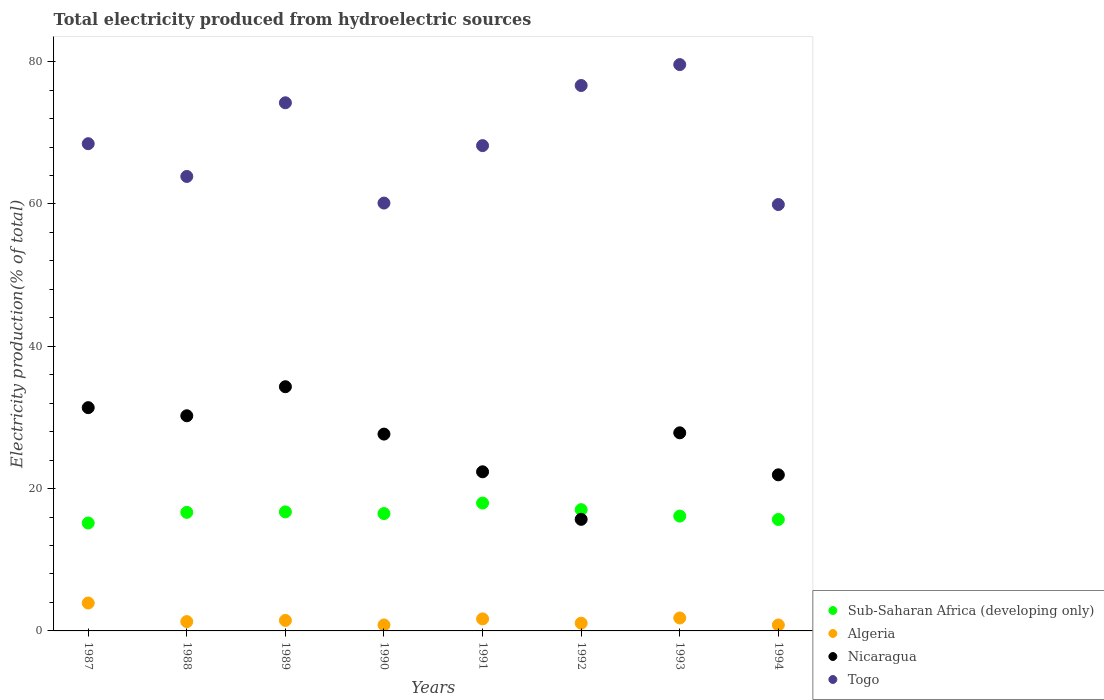Is the number of dotlines equal to the number of legend labels?
Provide a short and direct response. Yes. What is the total electricity produced in Nicaragua in 1988?
Provide a succinct answer. 30.23. Across all years, what is the maximum total electricity produced in Algeria?
Your answer should be compact. 3.92. Across all years, what is the minimum total electricity produced in Togo?
Your response must be concise. 59.92. In which year was the total electricity produced in Sub-Saharan Africa (developing only) maximum?
Your answer should be compact. 1991. What is the total total electricity produced in Togo in the graph?
Your response must be concise. 551.03. What is the difference between the total electricity produced in Sub-Saharan Africa (developing only) in 1992 and that in 1994?
Provide a succinct answer. 1.38. What is the difference between the total electricity produced in Nicaragua in 1993 and the total electricity produced in Algeria in 1987?
Your response must be concise. 23.92. What is the average total electricity produced in Togo per year?
Your answer should be compact. 68.88. In the year 1992, what is the difference between the total electricity produced in Sub-Saharan Africa (developing only) and total electricity produced in Nicaragua?
Your answer should be very brief. 1.36. What is the ratio of the total electricity produced in Togo in 1992 to that in 1994?
Provide a succinct answer. 1.28. Is the total electricity produced in Nicaragua in 1992 less than that in 1994?
Keep it short and to the point. Yes. What is the difference between the highest and the second highest total electricity produced in Togo?
Your answer should be compact. 2.94. What is the difference between the highest and the lowest total electricity produced in Nicaragua?
Provide a short and direct response. 18.64. Is it the case that in every year, the sum of the total electricity produced in Togo and total electricity produced in Algeria  is greater than the total electricity produced in Nicaragua?
Offer a very short reply. Yes. Are the values on the major ticks of Y-axis written in scientific E-notation?
Make the answer very short. No. Does the graph contain grids?
Offer a terse response. No. Where does the legend appear in the graph?
Make the answer very short. Bottom right. How are the legend labels stacked?
Make the answer very short. Vertical. What is the title of the graph?
Your answer should be compact. Total electricity produced from hydroelectric sources. Does "Albania" appear as one of the legend labels in the graph?
Keep it short and to the point. No. What is the Electricity production(% of total) in Sub-Saharan Africa (developing only) in 1987?
Offer a terse response. 15.17. What is the Electricity production(% of total) of Algeria in 1987?
Make the answer very short. 3.92. What is the Electricity production(% of total) in Nicaragua in 1987?
Your response must be concise. 31.38. What is the Electricity production(% of total) of Togo in 1987?
Ensure brevity in your answer.  68.47. What is the Electricity production(% of total) in Sub-Saharan Africa (developing only) in 1988?
Offer a very short reply. 16.66. What is the Electricity production(% of total) of Algeria in 1988?
Provide a succinct answer. 1.31. What is the Electricity production(% of total) of Nicaragua in 1988?
Ensure brevity in your answer.  30.23. What is the Electricity production(% of total) in Togo in 1988?
Give a very brief answer. 63.87. What is the Electricity production(% of total) of Sub-Saharan Africa (developing only) in 1989?
Give a very brief answer. 16.73. What is the Electricity production(% of total) in Algeria in 1989?
Ensure brevity in your answer.  1.47. What is the Electricity production(% of total) in Nicaragua in 1989?
Offer a very short reply. 34.32. What is the Electricity production(% of total) in Togo in 1989?
Provide a succinct answer. 74.22. What is the Electricity production(% of total) of Sub-Saharan Africa (developing only) in 1990?
Give a very brief answer. 16.49. What is the Electricity production(% of total) of Algeria in 1990?
Provide a short and direct response. 0.84. What is the Electricity production(% of total) of Nicaragua in 1990?
Provide a short and direct response. 27.66. What is the Electricity production(% of total) of Togo in 1990?
Offer a very short reply. 60.13. What is the Electricity production(% of total) in Sub-Saharan Africa (developing only) in 1991?
Provide a short and direct response. 17.97. What is the Electricity production(% of total) of Algeria in 1991?
Keep it short and to the point. 1.69. What is the Electricity production(% of total) of Nicaragua in 1991?
Your answer should be very brief. 22.36. What is the Electricity production(% of total) of Togo in 1991?
Offer a terse response. 68.2. What is the Electricity production(% of total) in Sub-Saharan Africa (developing only) in 1992?
Offer a very short reply. 17.04. What is the Electricity production(% of total) in Algeria in 1992?
Your answer should be compact. 1.09. What is the Electricity production(% of total) in Nicaragua in 1992?
Your response must be concise. 15.68. What is the Electricity production(% of total) in Togo in 1992?
Make the answer very short. 76.65. What is the Electricity production(% of total) of Sub-Saharan Africa (developing only) in 1993?
Provide a succinct answer. 16.14. What is the Electricity production(% of total) in Algeria in 1993?
Offer a very short reply. 1.82. What is the Electricity production(% of total) in Nicaragua in 1993?
Make the answer very short. 27.84. What is the Electricity production(% of total) of Togo in 1993?
Your answer should be compact. 79.58. What is the Electricity production(% of total) of Sub-Saharan Africa (developing only) in 1994?
Make the answer very short. 15.66. What is the Electricity production(% of total) in Algeria in 1994?
Offer a very short reply. 0.83. What is the Electricity production(% of total) of Nicaragua in 1994?
Make the answer very short. 21.94. What is the Electricity production(% of total) of Togo in 1994?
Keep it short and to the point. 59.92. Across all years, what is the maximum Electricity production(% of total) in Sub-Saharan Africa (developing only)?
Ensure brevity in your answer.  17.97. Across all years, what is the maximum Electricity production(% of total) of Algeria?
Make the answer very short. 3.92. Across all years, what is the maximum Electricity production(% of total) of Nicaragua?
Your response must be concise. 34.32. Across all years, what is the maximum Electricity production(% of total) of Togo?
Your answer should be compact. 79.58. Across all years, what is the minimum Electricity production(% of total) in Sub-Saharan Africa (developing only)?
Keep it short and to the point. 15.17. Across all years, what is the minimum Electricity production(% of total) in Algeria?
Provide a succinct answer. 0.83. Across all years, what is the minimum Electricity production(% of total) in Nicaragua?
Your answer should be very brief. 15.68. Across all years, what is the minimum Electricity production(% of total) in Togo?
Offer a very short reply. 59.92. What is the total Electricity production(% of total) of Sub-Saharan Africa (developing only) in the graph?
Offer a terse response. 131.85. What is the total Electricity production(% of total) in Algeria in the graph?
Provide a succinct answer. 12.98. What is the total Electricity production(% of total) in Nicaragua in the graph?
Your answer should be compact. 211.41. What is the total Electricity production(% of total) of Togo in the graph?
Make the answer very short. 551.03. What is the difference between the Electricity production(% of total) in Sub-Saharan Africa (developing only) in 1987 and that in 1988?
Your answer should be compact. -1.5. What is the difference between the Electricity production(% of total) of Algeria in 1987 and that in 1988?
Offer a very short reply. 2.61. What is the difference between the Electricity production(% of total) of Nicaragua in 1987 and that in 1988?
Provide a succinct answer. 1.14. What is the difference between the Electricity production(% of total) of Togo in 1987 and that in 1988?
Make the answer very short. 4.6. What is the difference between the Electricity production(% of total) of Sub-Saharan Africa (developing only) in 1987 and that in 1989?
Your response must be concise. -1.56. What is the difference between the Electricity production(% of total) in Algeria in 1987 and that in 1989?
Offer a terse response. 2.45. What is the difference between the Electricity production(% of total) in Nicaragua in 1987 and that in 1989?
Provide a short and direct response. -2.94. What is the difference between the Electricity production(% of total) in Togo in 1987 and that in 1989?
Give a very brief answer. -5.75. What is the difference between the Electricity production(% of total) of Sub-Saharan Africa (developing only) in 1987 and that in 1990?
Make the answer very short. -1.33. What is the difference between the Electricity production(% of total) of Algeria in 1987 and that in 1990?
Offer a terse response. 3.08. What is the difference between the Electricity production(% of total) in Nicaragua in 1987 and that in 1990?
Give a very brief answer. 3.72. What is the difference between the Electricity production(% of total) of Togo in 1987 and that in 1990?
Your response must be concise. 8.34. What is the difference between the Electricity production(% of total) of Sub-Saharan Africa (developing only) in 1987 and that in 1991?
Provide a short and direct response. -2.8. What is the difference between the Electricity production(% of total) of Algeria in 1987 and that in 1991?
Provide a succinct answer. 2.23. What is the difference between the Electricity production(% of total) of Nicaragua in 1987 and that in 1991?
Offer a very short reply. 9.01. What is the difference between the Electricity production(% of total) in Togo in 1987 and that in 1991?
Give a very brief answer. 0.27. What is the difference between the Electricity production(% of total) in Sub-Saharan Africa (developing only) in 1987 and that in 1992?
Provide a succinct answer. -1.87. What is the difference between the Electricity production(% of total) of Algeria in 1987 and that in 1992?
Offer a terse response. 2.83. What is the difference between the Electricity production(% of total) of Nicaragua in 1987 and that in 1992?
Give a very brief answer. 15.7. What is the difference between the Electricity production(% of total) in Togo in 1987 and that in 1992?
Provide a succinct answer. -8.18. What is the difference between the Electricity production(% of total) of Sub-Saharan Africa (developing only) in 1987 and that in 1993?
Your answer should be compact. -0.97. What is the difference between the Electricity production(% of total) in Algeria in 1987 and that in 1993?
Your answer should be very brief. 2.1. What is the difference between the Electricity production(% of total) in Nicaragua in 1987 and that in 1993?
Your answer should be very brief. 3.54. What is the difference between the Electricity production(% of total) of Togo in 1987 and that in 1993?
Your answer should be very brief. -11.12. What is the difference between the Electricity production(% of total) of Sub-Saharan Africa (developing only) in 1987 and that in 1994?
Make the answer very short. -0.5. What is the difference between the Electricity production(% of total) of Algeria in 1987 and that in 1994?
Your response must be concise. 3.09. What is the difference between the Electricity production(% of total) in Nicaragua in 1987 and that in 1994?
Your answer should be compact. 9.44. What is the difference between the Electricity production(% of total) in Togo in 1987 and that in 1994?
Your answer should be very brief. 8.55. What is the difference between the Electricity production(% of total) in Sub-Saharan Africa (developing only) in 1988 and that in 1989?
Your answer should be compact. -0.07. What is the difference between the Electricity production(% of total) of Algeria in 1988 and that in 1989?
Your answer should be very brief. -0.16. What is the difference between the Electricity production(% of total) of Nicaragua in 1988 and that in 1989?
Your answer should be compact. -4.08. What is the difference between the Electricity production(% of total) in Togo in 1988 and that in 1989?
Give a very brief answer. -10.35. What is the difference between the Electricity production(% of total) in Sub-Saharan Africa (developing only) in 1988 and that in 1990?
Give a very brief answer. 0.17. What is the difference between the Electricity production(% of total) of Algeria in 1988 and that in 1990?
Make the answer very short. 0.47. What is the difference between the Electricity production(% of total) of Nicaragua in 1988 and that in 1990?
Your answer should be compact. 2.57. What is the difference between the Electricity production(% of total) in Togo in 1988 and that in 1990?
Offer a very short reply. 3.74. What is the difference between the Electricity production(% of total) in Sub-Saharan Africa (developing only) in 1988 and that in 1991?
Make the answer very short. -1.31. What is the difference between the Electricity production(% of total) in Algeria in 1988 and that in 1991?
Offer a terse response. -0.38. What is the difference between the Electricity production(% of total) of Nicaragua in 1988 and that in 1991?
Make the answer very short. 7.87. What is the difference between the Electricity production(% of total) in Togo in 1988 and that in 1991?
Keep it short and to the point. -4.33. What is the difference between the Electricity production(% of total) of Sub-Saharan Africa (developing only) in 1988 and that in 1992?
Your response must be concise. -0.38. What is the difference between the Electricity production(% of total) in Algeria in 1988 and that in 1992?
Provide a short and direct response. 0.22. What is the difference between the Electricity production(% of total) of Nicaragua in 1988 and that in 1992?
Your response must be concise. 14.55. What is the difference between the Electricity production(% of total) of Togo in 1988 and that in 1992?
Ensure brevity in your answer.  -12.78. What is the difference between the Electricity production(% of total) of Sub-Saharan Africa (developing only) in 1988 and that in 1993?
Make the answer very short. 0.52. What is the difference between the Electricity production(% of total) in Algeria in 1988 and that in 1993?
Offer a terse response. -0.51. What is the difference between the Electricity production(% of total) of Nicaragua in 1988 and that in 1993?
Provide a succinct answer. 2.4. What is the difference between the Electricity production(% of total) of Togo in 1988 and that in 1993?
Your answer should be very brief. -15.72. What is the difference between the Electricity production(% of total) of Sub-Saharan Africa (developing only) in 1988 and that in 1994?
Give a very brief answer. 1. What is the difference between the Electricity production(% of total) in Algeria in 1988 and that in 1994?
Offer a very short reply. 0.48. What is the difference between the Electricity production(% of total) of Nicaragua in 1988 and that in 1994?
Offer a very short reply. 8.3. What is the difference between the Electricity production(% of total) in Togo in 1988 and that in 1994?
Your answer should be compact. 3.95. What is the difference between the Electricity production(% of total) of Sub-Saharan Africa (developing only) in 1989 and that in 1990?
Your answer should be very brief. 0.24. What is the difference between the Electricity production(% of total) in Algeria in 1989 and that in 1990?
Provide a succinct answer. 0.64. What is the difference between the Electricity production(% of total) of Nicaragua in 1989 and that in 1990?
Give a very brief answer. 6.66. What is the difference between the Electricity production(% of total) of Togo in 1989 and that in 1990?
Provide a succinct answer. 14.09. What is the difference between the Electricity production(% of total) of Sub-Saharan Africa (developing only) in 1989 and that in 1991?
Give a very brief answer. -1.24. What is the difference between the Electricity production(% of total) of Algeria in 1989 and that in 1991?
Ensure brevity in your answer.  -0.21. What is the difference between the Electricity production(% of total) of Nicaragua in 1989 and that in 1991?
Provide a succinct answer. 11.95. What is the difference between the Electricity production(% of total) of Togo in 1989 and that in 1991?
Your response must be concise. 6.02. What is the difference between the Electricity production(% of total) of Sub-Saharan Africa (developing only) in 1989 and that in 1992?
Provide a short and direct response. -0.31. What is the difference between the Electricity production(% of total) in Algeria in 1989 and that in 1992?
Your answer should be very brief. 0.39. What is the difference between the Electricity production(% of total) of Nicaragua in 1989 and that in 1992?
Your answer should be compact. 18.64. What is the difference between the Electricity production(% of total) in Togo in 1989 and that in 1992?
Your answer should be compact. -2.43. What is the difference between the Electricity production(% of total) of Sub-Saharan Africa (developing only) in 1989 and that in 1993?
Make the answer very short. 0.59. What is the difference between the Electricity production(% of total) in Algeria in 1989 and that in 1993?
Your answer should be compact. -0.34. What is the difference between the Electricity production(% of total) of Nicaragua in 1989 and that in 1993?
Keep it short and to the point. 6.48. What is the difference between the Electricity production(% of total) of Togo in 1989 and that in 1993?
Make the answer very short. -5.37. What is the difference between the Electricity production(% of total) in Sub-Saharan Africa (developing only) in 1989 and that in 1994?
Offer a very short reply. 1.07. What is the difference between the Electricity production(% of total) in Algeria in 1989 and that in 1994?
Your answer should be very brief. 0.64. What is the difference between the Electricity production(% of total) of Nicaragua in 1989 and that in 1994?
Your answer should be very brief. 12.38. What is the difference between the Electricity production(% of total) in Togo in 1989 and that in 1994?
Keep it short and to the point. 14.3. What is the difference between the Electricity production(% of total) in Sub-Saharan Africa (developing only) in 1990 and that in 1991?
Offer a very short reply. -1.48. What is the difference between the Electricity production(% of total) of Algeria in 1990 and that in 1991?
Provide a short and direct response. -0.85. What is the difference between the Electricity production(% of total) in Nicaragua in 1990 and that in 1991?
Ensure brevity in your answer.  5.3. What is the difference between the Electricity production(% of total) in Togo in 1990 and that in 1991?
Ensure brevity in your answer.  -8.07. What is the difference between the Electricity production(% of total) of Sub-Saharan Africa (developing only) in 1990 and that in 1992?
Ensure brevity in your answer.  -0.55. What is the difference between the Electricity production(% of total) in Algeria in 1990 and that in 1992?
Provide a succinct answer. -0.25. What is the difference between the Electricity production(% of total) in Nicaragua in 1990 and that in 1992?
Give a very brief answer. 11.98. What is the difference between the Electricity production(% of total) of Togo in 1990 and that in 1992?
Offer a very short reply. -16.52. What is the difference between the Electricity production(% of total) of Sub-Saharan Africa (developing only) in 1990 and that in 1993?
Give a very brief answer. 0.35. What is the difference between the Electricity production(% of total) in Algeria in 1990 and that in 1993?
Your response must be concise. -0.98. What is the difference between the Electricity production(% of total) of Nicaragua in 1990 and that in 1993?
Your answer should be compact. -0.18. What is the difference between the Electricity production(% of total) in Togo in 1990 and that in 1993?
Give a very brief answer. -19.46. What is the difference between the Electricity production(% of total) of Sub-Saharan Africa (developing only) in 1990 and that in 1994?
Make the answer very short. 0.83. What is the difference between the Electricity production(% of total) in Algeria in 1990 and that in 1994?
Give a very brief answer. 0. What is the difference between the Electricity production(% of total) of Nicaragua in 1990 and that in 1994?
Ensure brevity in your answer.  5.72. What is the difference between the Electricity production(% of total) in Togo in 1990 and that in 1994?
Give a very brief answer. 0.21. What is the difference between the Electricity production(% of total) in Sub-Saharan Africa (developing only) in 1991 and that in 1992?
Provide a succinct answer. 0.93. What is the difference between the Electricity production(% of total) of Algeria in 1991 and that in 1992?
Provide a short and direct response. 0.6. What is the difference between the Electricity production(% of total) of Nicaragua in 1991 and that in 1992?
Offer a very short reply. 6.68. What is the difference between the Electricity production(% of total) of Togo in 1991 and that in 1992?
Offer a terse response. -8.45. What is the difference between the Electricity production(% of total) in Sub-Saharan Africa (developing only) in 1991 and that in 1993?
Keep it short and to the point. 1.83. What is the difference between the Electricity production(% of total) of Algeria in 1991 and that in 1993?
Ensure brevity in your answer.  -0.13. What is the difference between the Electricity production(% of total) of Nicaragua in 1991 and that in 1993?
Ensure brevity in your answer.  -5.48. What is the difference between the Electricity production(% of total) in Togo in 1991 and that in 1993?
Provide a short and direct response. -11.39. What is the difference between the Electricity production(% of total) of Sub-Saharan Africa (developing only) in 1991 and that in 1994?
Make the answer very short. 2.31. What is the difference between the Electricity production(% of total) in Algeria in 1991 and that in 1994?
Provide a succinct answer. 0.85. What is the difference between the Electricity production(% of total) of Nicaragua in 1991 and that in 1994?
Your answer should be compact. 0.43. What is the difference between the Electricity production(% of total) in Togo in 1991 and that in 1994?
Offer a very short reply. 8.28. What is the difference between the Electricity production(% of total) of Sub-Saharan Africa (developing only) in 1992 and that in 1993?
Ensure brevity in your answer.  0.9. What is the difference between the Electricity production(% of total) in Algeria in 1992 and that in 1993?
Keep it short and to the point. -0.73. What is the difference between the Electricity production(% of total) in Nicaragua in 1992 and that in 1993?
Make the answer very short. -12.16. What is the difference between the Electricity production(% of total) in Togo in 1992 and that in 1993?
Make the answer very short. -2.94. What is the difference between the Electricity production(% of total) of Sub-Saharan Africa (developing only) in 1992 and that in 1994?
Offer a very short reply. 1.38. What is the difference between the Electricity production(% of total) in Algeria in 1992 and that in 1994?
Offer a very short reply. 0.25. What is the difference between the Electricity production(% of total) of Nicaragua in 1992 and that in 1994?
Your answer should be compact. -6.26. What is the difference between the Electricity production(% of total) in Togo in 1992 and that in 1994?
Make the answer very short. 16.73. What is the difference between the Electricity production(% of total) of Sub-Saharan Africa (developing only) in 1993 and that in 1994?
Ensure brevity in your answer.  0.48. What is the difference between the Electricity production(% of total) of Algeria in 1993 and that in 1994?
Your answer should be compact. 0.98. What is the difference between the Electricity production(% of total) in Nicaragua in 1993 and that in 1994?
Your answer should be compact. 5.9. What is the difference between the Electricity production(% of total) of Togo in 1993 and that in 1994?
Offer a very short reply. 19.67. What is the difference between the Electricity production(% of total) in Sub-Saharan Africa (developing only) in 1987 and the Electricity production(% of total) in Algeria in 1988?
Provide a short and direct response. 13.86. What is the difference between the Electricity production(% of total) in Sub-Saharan Africa (developing only) in 1987 and the Electricity production(% of total) in Nicaragua in 1988?
Provide a succinct answer. -15.07. What is the difference between the Electricity production(% of total) in Sub-Saharan Africa (developing only) in 1987 and the Electricity production(% of total) in Togo in 1988?
Your answer should be compact. -48.7. What is the difference between the Electricity production(% of total) of Algeria in 1987 and the Electricity production(% of total) of Nicaragua in 1988?
Offer a terse response. -26.31. What is the difference between the Electricity production(% of total) in Algeria in 1987 and the Electricity production(% of total) in Togo in 1988?
Ensure brevity in your answer.  -59.94. What is the difference between the Electricity production(% of total) in Nicaragua in 1987 and the Electricity production(% of total) in Togo in 1988?
Give a very brief answer. -32.49. What is the difference between the Electricity production(% of total) in Sub-Saharan Africa (developing only) in 1987 and the Electricity production(% of total) in Algeria in 1989?
Keep it short and to the point. 13.69. What is the difference between the Electricity production(% of total) in Sub-Saharan Africa (developing only) in 1987 and the Electricity production(% of total) in Nicaragua in 1989?
Your answer should be very brief. -19.15. What is the difference between the Electricity production(% of total) in Sub-Saharan Africa (developing only) in 1987 and the Electricity production(% of total) in Togo in 1989?
Give a very brief answer. -59.05. What is the difference between the Electricity production(% of total) in Algeria in 1987 and the Electricity production(% of total) in Nicaragua in 1989?
Your response must be concise. -30.39. What is the difference between the Electricity production(% of total) in Algeria in 1987 and the Electricity production(% of total) in Togo in 1989?
Provide a short and direct response. -70.3. What is the difference between the Electricity production(% of total) in Nicaragua in 1987 and the Electricity production(% of total) in Togo in 1989?
Your response must be concise. -42.84. What is the difference between the Electricity production(% of total) of Sub-Saharan Africa (developing only) in 1987 and the Electricity production(% of total) of Algeria in 1990?
Ensure brevity in your answer.  14.33. What is the difference between the Electricity production(% of total) of Sub-Saharan Africa (developing only) in 1987 and the Electricity production(% of total) of Nicaragua in 1990?
Provide a short and direct response. -12.49. What is the difference between the Electricity production(% of total) of Sub-Saharan Africa (developing only) in 1987 and the Electricity production(% of total) of Togo in 1990?
Ensure brevity in your answer.  -44.96. What is the difference between the Electricity production(% of total) in Algeria in 1987 and the Electricity production(% of total) in Nicaragua in 1990?
Your answer should be very brief. -23.74. What is the difference between the Electricity production(% of total) in Algeria in 1987 and the Electricity production(% of total) in Togo in 1990?
Provide a short and direct response. -56.2. What is the difference between the Electricity production(% of total) of Nicaragua in 1987 and the Electricity production(% of total) of Togo in 1990?
Offer a very short reply. -28.75. What is the difference between the Electricity production(% of total) of Sub-Saharan Africa (developing only) in 1987 and the Electricity production(% of total) of Algeria in 1991?
Provide a short and direct response. 13.48. What is the difference between the Electricity production(% of total) in Sub-Saharan Africa (developing only) in 1987 and the Electricity production(% of total) in Nicaragua in 1991?
Your answer should be very brief. -7.2. What is the difference between the Electricity production(% of total) in Sub-Saharan Africa (developing only) in 1987 and the Electricity production(% of total) in Togo in 1991?
Make the answer very short. -53.03. What is the difference between the Electricity production(% of total) of Algeria in 1987 and the Electricity production(% of total) of Nicaragua in 1991?
Keep it short and to the point. -18.44. What is the difference between the Electricity production(% of total) of Algeria in 1987 and the Electricity production(% of total) of Togo in 1991?
Ensure brevity in your answer.  -64.28. What is the difference between the Electricity production(% of total) in Nicaragua in 1987 and the Electricity production(% of total) in Togo in 1991?
Offer a terse response. -36.82. What is the difference between the Electricity production(% of total) of Sub-Saharan Africa (developing only) in 1987 and the Electricity production(% of total) of Algeria in 1992?
Give a very brief answer. 14.08. What is the difference between the Electricity production(% of total) in Sub-Saharan Africa (developing only) in 1987 and the Electricity production(% of total) in Nicaragua in 1992?
Offer a very short reply. -0.51. What is the difference between the Electricity production(% of total) of Sub-Saharan Africa (developing only) in 1987 and the Electricity production(% of total) of Togo in 1992?
Give a very brief answer. -61.48. What is the difference between the Electricity production(% of total) in Algeria in 1987 and the Electricity production(% of total) in Nicaragua in 1992?
Offer a terse response. -11.76. What is the difference between the Electricity production(% of total) of Algeria in 1987 and the Electricity production(% of total) of Togo in 1992?
Offer a terse response. -72.72. What is the difference between the Electricity production(% of total) in Nicaragua in 1987 and the Electricity production(% of total) in Togo in 1992?
Make the answer very short. -45.27. What is the difference between the Electricity production(% of total) in Sub-Saharan Africa (developing only) in 1987 and the Electricity production(% of total) in Algeria in 1993?
Offer a very short reply. 13.35. What is the difference between the Electricity production(% of total) in Sub-Saharan Africa (developing only) in 1987 and the Electricity production(% of total) in Nicaragua in 1993?
Offer a terse response. -12.67. What is the difference between the Electricity production(% of total) of Sub-Saharan Africa (developing only) in 1987 and the Electricity production(% of total) of Togo in 1993?
Offer a very short reply. -64.42. What is the difference between the Electricity production(% of total) of Algeria in 1987 and the Electricity production(% of total) of Nicaragua in 1993?
Ensure brevity in your answer.  -23.92. What is the difference between the Electricity production(% of total) in Algeria in 1987 and the Electricity production(% of total) in Togo in 1993?
Your answer should be compact. -75.66. What is the difference between the Electricity production(% of total) of Nicaragua in 1987 and the Electricity production(% of total) of Togo in 1993?
Your answer should be compact. -48.21. What is the difference between the Electricity production(% of total) in Sub-Saharan Africa (developing only) in 1987 and the Electricity production(% of total) in Algeria in 1994?
Your response must be concise. 14.33. What is the difference between the Electricity production(% of total) of Sub-Saharan Africa (developing only) in 1987 and the Electricity production(% of total) of Nicaragua in 1994?
Keep it short and to the point. -6.77. What is the difference between the Electricity production(% of total) of Sub-Saharan Africa (developing only) in 1987 and the Electricity production(% of total) of Togo in 1994?
Offer a terse response. -44.75. What is the difference between the Electricity production(% of total) of Algeria in 1987 and the Electricity production(% of total) of Nicaragua in 1994?
Ensure brevity in your answer.  -18.01. What is the difference between the Electricity production(% of total) of Algeria in 1987 and the Electricity production(% of total) of Togo in 1994?
Your answer should be compact. -56. What is the difference between the Electricity production(% of total) in Nicaragua in 1987 and the Electricity production(% of total) in Togo in 1994?
Make the answer very short. -28.54. What is the difference between the Electricity production(% of total) in Sub-Saharan Africa (developing only) in 1988 and the Electricity production(% of total) in Algeria in 1989?
Your answer should be very brief. 15.19. What is the difference between the Electricity production(% of total) of Sub-Saharan Africa (developing only) in 1988 and the Electricity production(% of total) of Nicaragua in 1989?
Make the answer very short. -17.66. What is the difference between the Electricity production(% of total) of Sub-Saharan Africa (developing only) in 1988 and the Electricity production(% of total) of Togo in 1989?
Make the answer very short. -57.56. What is the difference between the Electricity production(% of total) in Algeria in 1988 and the Electricity production(% of total) in Nicaragua in 1989?
Provide a succinct answer. -33.01. What is the difference between the Electricity production(% of total) of Algeria in 1988 and the Electricity production(% of total) of Togo in 1989?
Your response must be concise. -72.91. What is the difference between the Electricity production(% of total) in Nicaragua in 1988 and the Electricity production(% of total) in Togo in 1989?
Your answer should be compact. -43.98. What is the difference between the Electricity production(% of total) of Sub-Saharan Africa (developing only) in 1988 and the Electricity production(% of total) of Algeria in 1990?
Your response must be concise. 15.82. What is the difference between the Electricity production(% of total) in Sub-Saharan Africa (developing only) in 1988 and the Electricity production(% of total) in Nicaragua in 1990?
Your answer should be very brief. -11. What is the difference between the Electricity production(% of total) of Sub-Saharan Africa (developing only) in 1988 and the Electricity production(% of total) of Togo in 1990?
Provide a succinct answer. -43.47. What is the difference between the Electricity production(% of total) in Algeria in 1988 and the Electricity production(% of total) in Nicaragua in 1990?
Your response must be concise. -26.35. What is the difference between the Electricity production(% of total) in Algeria in 1988 and the Electricity production(% of total) in Togo in 1990?
Your answer should be compact. -58.82. What is the difference between the Electricity production(% of total) of Nicaragua in 1988 and the Electricity production(% of total) of Togo in 1990?
Your answer should be very brief. -29.89. What is the difference between the Electricity production(% of total) of Sub-Saharan Africa (developing only) in 1988 and the Electricity production(% of total) of Algeria in 1991?
Keep it short and to the point. 14.97. What is the difference between the Electricity production(% of total) of Sub-Saharan Africa (developing only) in 1988 and the Electricity production(% of total) of Nicaragua in 1991?
Provide a succinct answer. -5.7. What is the difference between the Electricity production(% of total) in Sub-Saharan Africa (developing only) in 1988 and the Electricity production(% of total) in Togo in 1991?
Your answer should be compact. -51.54. What is the difference between the Electricity production(% of total) in Algeria in 1988 and the Electricity production(% of total) in Nicaragua in 1991?
Provide a succinct answer. -21.05. What is the difference between the Electricity production(% of total) in Algeria in 1988 and the Electricity production(% of total) in Togo in 1991?
Provide a short and direct response. -66.89. What is the difference between the Electricity production(% of total) of Nicaragua in 1988 and the Electricity production(% of total) of Togo in 1991?
Your response must be concise. -37.96. What is the difference between the Electricity production(% of total) of Sub-Saharan Africa (developing only) in 1988 and the Electricity production(% of total) of Algeria in 1992?
Your answer should be very brief. 15.57. What is the difference between the Electricity production(% of total) of Sub-Saharan Africa (developing only) in 1988 and the Electricity production(% of total) of Nicaragua in 1992?
Your answer should be very brief. 0.98. What is the difference between the Electricity production(% of total) of Sub-Saharan Africa (developing only) in 1988 and the Electricity production(% of total) of Togo in 1992?
Your response must be concise. -59.99. What is the difference between the Electricity production(% of total) of Algeria in 1988 and the Electricity production(% of total) of Nicaragua in 1992?
Ensure brevity in your answer.  -14.37. What is the difference between the Electricity production(% of total) of Algeria in 1988 and the Electricity production(% of total) of Togo in 1992?
Offer a very short reply. -75.34. What is the difference between the Electricity production(% of total) in Nicaragua in 1988 and the Electricity production(% of total) in Togo in 1992?
Give a very brief answer. -46.41. What is the difference between the Electricity production(% of total) of Sub-Saharan Africa (developing only) in 1988 and the Electricity production(% of total) of Algeria in 1993?
Give a very brief answer. 14.84. What is the difference between the Electricity production(% of total) in Sub-Saharan Africa (developing only) in 1988 and the Electricity production(% of total) in Nicaragua in 1993?
Your answer should be very brief. -11.18. What is the difference between the Electricity production(% of total) of Sub-Saharan Africa (developing only) in 1988 and the Electricity production(% of total) of Togo in 1993?
Provide a succinct answer. -62.92. What is the difference between the Electricity production(% of total) of Algeria in 1988 and the Electricity production(% of total) of Nicaragua in 1993?
Provide a succinct answer. -26.53. What is the difference between the Electricity production(% of total) in Algeria in 1988 and the Electricity production(% of total) in Togo in 1993?
Provide a short and direct response. -78.27. What is the difference between the Electricity production(% of total) of Nicaragua in 1988 and the Electricity production(% of total) of Togo in 1993?
Your answer should be compact. -49.35. What is the difference between the Electricity production(% of total) in Sub-Saharan Africa (developing only) in 1988 and the Electricity production(% of total) in Algeria in 1994?
Provide a short and direct response. 15.83. What is the difference between the Electricity production(% of total) in Sub-Saharan Africa (developing only) in 1988 and the Electricity production(% of total) in Nicaragua in 1994?
Provide a succinct answer. -5.28. What is the difference between the Electricity production(% of total) in Sub-Saharan Africa (developing only) in 1988 and the Electricity production(% of total) in Togo in 1994?
Your response must be concise. -43.26. What is the difference between the Electricity production(% of total) in Algeria in 1988 and the Electricity production(% of total) in Nicaragua in 1994?
Your response must be concise. -20.63. What is the difference between the Electricity production(% of total) in Algeria in 1988 and the Electricity production(% of total) in Togo in 1994?
Your response must be concise. -58.61. What is the difference between the Electricity production(% of total) in Nicaragua in 1988 and the Electricity production(% of total) in Togo in 1994?
Offer a very short reply. -29.68. What is the difference between the Electricity production(% of total) of Sub-Saharan Africa (developing only) in 1989 and the Electricity production(% of total) of Algeria in 1990?
Your answer should be very brief. 15.89. What is the difference between the Electricity production(% of total) of Sub-Saharan Africa (developing only) in 1989 and the Electricity production(% of total) of Nicaragua in 1990?
Your answer should be very brief. -10.93. What is the difference between the Electricity production(% of total) of Sub-Saharan Africa (developing only) in 1989 and the Electricity production(% of total) of Togo in 1990?
Provide a succinct answer. -43.4. What is the difference between the Electricity production(% of total) in Algeria in 1989 and the Electricity production(% of total) in Nicaragua in 1990?
Provide a short and direct response. -26.18. What is the difference between the Electricity production(% of total) in Algeria in 1989 and the Electricity production(% of total) in Togo in 1990?
Give a very brief answer. -58.65. What is the difference between the Electricity production(% of total) of Nicaragua in 1989 and the Electricity production(% of total) of Togo in 1990?
Your answer should be compact. -25.81. What is the difference between the Electricity production(% of total) of Sub-Saharan Africa (developing only) in 1989 and the Electricity production(% of total) of Algeria in 1991?
Make the answer very short. 15.04. What is the difference between the Electricity production(% of total) in Sub-Saharan Africa (developing only) in 1989 and the Electricity production(% of total) in Nicaragua in 1991?
Make the answer very short. -5.63. What is the difference between the Electricity production(% of total) in Sub-Saharan Africa (developing only) in 1989 and the Electricity production(% of total) in Togo in 1991?
Provide a short and direct response. -51.47. What is the difference between the Electricity production(% of total) in Algeria in 1989 and the Electricity production(% of total) in Nicaragua in 1991?
Offer a terse response. -20.89. What is the difference between the Electricity production(% of total) in Algeria in 1989 and the Electricity production(% of total) in Togo in 1991?
Provide a succinct answer. -66.72. What is the difference between the Electricity production(% of total) of Nicaragua in 1989 and the Electricity production(% of total) of Togo in 1991?
Provide a short and direct response. -33.88. What is the difference between the Electricity production(% of total) of Sub-Saharan Africa (developing only) in 1989 and the Electricity production(% of total) of Algeria in 1992?
Your answer should be very brief. 15.64. What is the difference between the Electricity production(% of total) in Sub-Saharan Africa (developing only) in 1989 and the Electricity production(% of total) in Nicaragua in 1992?
Your answer should be compact. 1.05. What is the difference between the Electricity production(% of total) of Sub-Saharan Africa (developing only) in 1989 and the Electricity production(% of total) of Togo in 1992?
Give a very brief answer. -59.92. What is the difference between the Electricity production(% of total) of Algeria in 1989 and the Electricity production(% of total) of Nicaragua in 1992?
Your response must be concise. -14.21. What is the difference between the Electricity production(% of total) in Algeria in 1989 and the Electricity production(% of total) in Togo in 1992?
Make the answer very short. -75.17. What is the difference between the Electricity production(% of total) in Nicaragua in 1989 and the Electricity production(% of total) in Togo in 1992?
Make the answer very short. -42.33. What is the difference between the Electricity production(% of total) in Sub-Saharan Africa (developing only) in 1989 and the Electricity production(% of total) in Algeria in 1993?
Make the answer very short. 14.91. What is the difference between the Electricity production(% of total) of Sub-Saharan Africa (developing only) in 1989 and the Electricity production(% of total) of Nicaragua in 1993?
Your answer should be compact. -11.11. What is the difference between the Electricity production(% of total) of Sub-Saharan Africa (developing only) in 1989 and the Electricity production(% of total) of Togo in 1993?
Make the answer very short. -62.86. What is the difference between the Electricity production(% of total) in Algeria in 1989 and the Electricity production(% of total) in Nicaragua in 1993?
Ensure brevity in your answer.  -26.36. What is the difference between the Electricity production(% of total) of Algeria in 1989 and the Electricity production(% of total) of Togo in 1993?
Provide a short and direct response. -78.11. What is the difference between the Electricity production(% of total) in Nicaragua in 1989 and the Electricity production(% of total) in Togo in 1993?
Provide a succinct answer. -45.27. What is the difference between the Electricity production(% of total) in Sub-Saharan Africa (developing only) in 1989 and the Electricity production(% of total) in Algeria in 1994?
Make the answer very short. 15.89. What is the difference between the Electricity production(% of total) in Sub-Saharan Africa (developing only) in 1989 and the Electricity production(% of total) in Nicaragua in 1994?
Offer a very short reply. -5.21. What is the difference between the Electricity production(% of total) in Sub-Saharan Africa (developing only) in 1989 and the Electricity production(% of total) in Togo in 1994?
Ensure brevity in your answer.  -43.19. What is the difference between the Electricity production(% of total) of Algeria in 1989 and the Electricity production(% of total) of Nicaragua in 1994?
Offer a very short reply. -20.46. What is the difference between the Electricity production(% of total) in Algeria in 1989 and the Electricity production(% of total) in Togo in 1994?
Your answer should be compact. -58.44. What is the difference between the Electricity production(% of total) of Nicaragua in 1989 and the Electricity production(% of total) of Togo in 1994?
Give a very brief answer. -25.6. What is the difference between the Electricity production(% of total) in Sub-Saharan Africa (developing only) in 1990 and the Electricity production(% of total) in Algeria in 1991?
Provide a short and direct response. 14.8. What is the difference between the Electricity production(% of total) of Sub-Saharan Africa (developing only) in 1990 and the Electricity production(% of total) of Nicaragua in 1991?
Provide a short and direct response. -5.87. What is the difference between the Electricity production(% of total) of Sub-Saharan Africa (developing only) in 1990 and the Electricity production(% of total) of Togo in 1991?
Your answer should be very brief. -51.71. What is the difference between the Electricity production(% of total) in Algeria in 1990 and the Electricity production(% of total) in Nicaragua in 1991?
Your response must be concise. -21.52. What is the difference between the Electricity production(% of total) of Algeria in 1990 and the Electricity production(% of total) of Togo in 1991?
Offer a terse response. -67.36. What is the difference between the Electricity production(% of total) in Nicaragua in 1990 and the Electricity production(% of total) in Togo in 1991?
Give a very brief answer. -40.54. What is the difference between the Electricity production(% of total) of Sub-Saharan Africa (developing only) in 1990 and the Electricity production(% of total) of Algeria in 1992?
Keep it short and to the point. 15.4. What is the difference between the Electricity production(% of total) of Sub-Saharan Africa (developing only) in 1990 and the Electricity production(% of total) of Nicaragua in 1992?
Make the answer very short. 0.81. What is the difference between the Electricity production(% of total) in Sub-Saharan Africa (developing only) in 1990 and the Electricity production(% of total) in Togo in 1992?
Give a very brief answer. -60.16. What is the difference between the Electricity production(% of total) of Algeria in 1990 and the Electricity production(% of total) of Nicaragua in 1992?
Keep it short and to the point. -14.84. What is the difference between the Electricity production(% of total) of Algeria in 1990 and the Electricity production(% of total) of Togo in 1992?
Ensure brevity in your answer.  -75.81. What is the difference between the Electricity production(% of total) of Nicaragua in 1990 and the Electricity production(% of total) of Togo in 1992?
Offer a terse response. -48.99. What is the difference between the Electricity production(% of total) in Sub-Saharan Africa (developing only) in 1990 and the Electricity production(% of total) in Algeria in 1993?
Provide a succinct answer. 14.67. What is the difference between the Electricity production(% of total) of Sub-Saharan Africa (developing only) in 1990 and the Electricity production(% of total) of Nicaragua in 1993?
Give a very brief answer. -11.35. What is the difference between the Electricity production(% of total) in Sub-Saharan Africa (developing only) in 1990 and the Electricity production(% of total) in Togo in 1993?
Your answer should be very brief. -63.09. What is the difference between the Electricity production(% of total) of Algeria in 1990 and the Electricity production(% of total) of Nicaragua in 1993?
Offer a very short reply. -27. What is the difference between the Electricity production(% of total) of Algeria in 1990 and the Electricity production(% of total) of Togo in 1993?
Provide a succinct answer. -78.75. What is the difference between the Electricity production(% of total) in Nicaragua in 1990 and the Electricity production(% of total) in Togo in 1993?
Your answer should be very brief. -51.93. What is the difference between the Electricity production(% of total) in Sub-Saharan Africa (developing only) in 1990 and the Electricity production(% of total) in Algeria in 1994?
Give a very brief answer. 15.66. What is the difference between the Electricity production(% of total) in Sub-Saharan Africa (developing only) in 1990 and the Electricity production(% of total) in Nicaragua in 1994?
Your answer should be compact. -5.44. What is the difference between the Electricity production(% of total) in Sub-Saharan Africa (developing only) in 1990 and the Electricity production(% of total) in Togo in 1994?
Make the answer very short. -43.43. What is the difference between the Electricity production(% of total) in Algeria in 1990 and the Electricity production(% of total) in Nicaragua in 1994?
Provide a succinct answer. -21.1. What is the difference between the Electricity production(% of total) of Algeria in 1990 and the Electricity production(% of total) of Togo in 1994?
Give a very brief answer. -59.08. What is the difference between the Electricity production(% of total) in Nicaragua in 1990 and the Electricity production(% of total) in Togo in 1994?
Your answer should be compact. -32.26. What is the difference between the Electricity production(% of total) of Sub-Saharan Africa (developing only) in 1991 and the Electricity production(% of total) of Algeria in 1992?
Provide a short and direct response. 16.88. What is the difference between the Electricity production(% of total) of Sub-Saharan Africa (developing only) in 1991 and the Electricity production(% of total) of Nicaragua in 1992?
Make the answer very short. 2.29. What is the difference between the Electricity production(% of total) of Sub-Saharan Africa (developing only) in 1991 and the Electricity production(% of total) of Togo in 1992?
Provide a succinct answer. -58.68. What is the difference between the Electricity production(% of total) of Algeria in 1991 and the Electricity production(% of total) of Nicaragua in 1992?
Your answer should be compact. -13.99. What is the difference between the Electricity production(% of total) of Algeria in 1991 and the Electricity production(% of total) of Togo in 1992?
Your answer should be very brief. -74.96. What is the difference between the Electricity production(% of total) of Nicaragua in 1991 and the Electricity production(% of total) of Togo in 1992?
Offer a very short reply. -54.28. What is the difference between the Electricity production(% of total) of Sub-Saharan Africa (developing only) in 1991 and the Electricity production(% of total) of Algeria in 1993?
Make the answer very short. 16.15. What is the difference between the Electricity production(% of total) in Sub-Saharan Africa (developing only) in 1991 and the Electricity production(% of total) in Nicaragua in 1993?
Ensure brevity in your answer.  -9.87. What is the difference between the Electricity production(% of total) in Sub-Saharan Africa (developing only) in 1991 and the Electricity production(% of total) in Togo in 1993?
Give a very brief answer. -61.62. What is the difference between the Electricity production(% of total) in Algeria in 1991 and the Electricity production(% of total) in Nicaragua in 1993?
Keep it short and to the point. -26.15. What is the difference between the Electricity production(% of total) of Algeria in 1991 and the Electricity production(% of total) of Togo in 1993?
Your response must be concise. -77.9. What is the difference between the Electricity production(% of total) of Nicaragua in 1991 and the Electricity production(% of total) of Togo in 1993?
Your answer should be very brief. -57.22. What is the difference between the Electricity production(% of total) of Sub-Saharan Africa (developing only) in 1991 and the Electricity production(% of total) of Algeria in 1994?
Your response must be concise. 17.13. What is the difference between the Electricity production(% of total) in Sub-Saharan Africa (developing only) in 1991 and the Electricity production(% of total) in Nicaragua in 1994?
Offer a terse response. -3.97. What is the difference between the Electricity production(% of total) in Sub-Saharan Africa (developing only) in 1991 and the Electricity production(% of total) in Togo in 1994?
Offer a terse response. -41.95. What is the difference between the Electricity production(% of total) of Algeria in 1991 and the Electricity production(% of total) of Nicaragua in 1994?
Your answer should be very brief. -20.25. What is the difference between the Electricity production(% of total) in Algeria in 1991 and the Electricity production(% of total) in Togo in 1994?
Your response must be concise. -58.23. What is the difference between the Electricity production(% of total) in Nicaragua in 1991 and the Electricity production(% of total) in Togo in 1994?
Your answer should be very brief. -37.56. What is the difference between the Electricity production(% of total) in Sub-Saharan Africa (developing only) in 1992 and the Electricity production(% of total) in Algeria in 1993?
Offer a very short reply. 15.22. What is the difference between the Electricity production(% of total) of Sub-Saharan Africa (developing only) in 1992 and the Electricity production(% of total) of Nicaragua in 1993?
Provide a succinct answer. -10.8. What is the difference between the Electricity production(% of total) in Sub-Saharan Africa (developing only) in 1992 and the Electricity production(% of total) in Togo in 1993?
Offer a terse response. -62.55. What is the difference between the Electricity production(% of total) of Algeria in 1992 and the Electricity production(% of total) of Nicaragua in 1993?
Offer a terse response. -26.75. What is the difference between the Electricity production(% of total) of Algeria in 1992 and the Electricity production(% of total) of Togo in 1993?
Your answer should be very brief. -78.5. What is the difference between the Electricity production(% of total) of Nicaragua in 1992 and the Electricity production(% of total) of Togo in 1993?
Offer a terse response. -63.9. What is the difference between the Electricity production(% of total) in Sub-Saharan Africa (developing only) in 1992 and the Electricity production(% of total) in Algeria in 1994?
Give a very brief answer. 16.2. What is the difference between the Electricity production(% of total) in Sub-Saharan Africa (developing only) in 1992 and the Electricity production(% of total) in Nicaragua in 1994?
Offer a very short reply. -4.9. What is the difference between the Electricity production(% of total) in Sub-Saharan Africa (developing only) in 1992 and the Electricity production(% of total) in Togo in 1994?
Offer a terse response. -42.88. What is the difference between the Electricity production(% of total) of Algeria in 1992 and the Electricity production(% of total) of Nicaragua in 1994?
Ensure brevity in your answer.  -20.85. What is the difference between the Electricity production(% of total) in Algeria in 1992 and the Electricity production(% of total) in Togo in 1994?
Offer a terse response. -58.83. What is the difference between the Electricity production(% of total) in Nicaragua in 1992 and the Electricity production(% of total) in Togo in 1994?
Provide a succinct answer. -44.24. What is the difference between the Electricity production(% of total) of Sub-Saharan Africa (developing only) in 1993 and the Electricity production(% of total) of Algeria in 1994?
Offer a very short reply. 15.3. What is the difference between the Electricity production(% of total) in Sub-Saharan Africa (developing only) in 1993 and the Electricity production(% of total) in Nicaragua in 1994?
Your response must be concise. -5.8. What is the difference between the Electricity production(% of total) of Sub-Saharan Africa (developing only) in 1993 and the Electricity production(% of total) of Togo in 1994?
Offer a terse response. -43.78. What is the difference between the Electricity production(% of total) of Algeria in 1993 and the Electricity production(% of total) of Nicaragua in 1994?
Provide a short and direct response. -20.12. What is the difference between the Electricity production(% of total) in Algeria in 1993 and the Electricity production(% of total) in Togo in 1994?
Your response must be concise. -58.1. What is the difference between the Electricity production(% of total) in Nicaragua in 1993 and the Electricity production(% of total) in Togo in 1994?
Offer a terse response. -32.08. What is the average Electricity production(% of total) of Sub-Saharan Africa (developing only) per year?
Your answer should be very brief. 16.48. What is the average Electricity production(% of total) in Algeria per year?
Keep it short and to the point. 1.62. What is the average Electricity production(% of total) in Nicaragua per year?
Keep it short and to the point. 26.43. What is the average Electricity production(% of total) of Togo per year?
Your response must be concise. 68.88. In the year 1987, what is the difference between the Electricity production(% of total) of Sub-Saharan Africa (developing only) and Electricity production(% of total) of Algeria?
Make the answer very short. 11.24. In the year 1987, what is the difference between the Electricity production(% of total) of Sub-Saharan Africa (developing only) and Electricity production(% of total) of Nicaragua?
Give a very brief answer. -16.21. In the year 1987, what is the difference between the Electricity production(% of total) in Sub-Saharan Africa (developing only) and Electricity production(% of total) in Togo?
Make the answer very short. -53.3. In the year 1987, what is the difference between the Electricity production(% of total) of Algeria and Electricity production(% of total) of Nicaragua?
Give a very brief answer. -27.45. In the year 1987, what is the difference between the Electricity production(% of total) of Algeria and Electricity production(% of total) of Togo?
Make the answer very short. -64.55. In the year 1987, what is the difference between the Electricity production(% of total) in Nicaragua and Electricity production(% of total) in Togo?
Keep it short and to the point. -37.09. In the year 1988, what is the difference between the Electricity production(% of total) in Sub-Saharan Africa (developing only) and Electricity production(% of total) in Algeria?
Ensure brevity in your answer.  15.35. In the year 1988, what is the difference between the Electricity production(% of total) in Sub-Saharan Africa (developing only) and Electricity production(% of total) in Nicaragua?
Ensure brevity in your answer.  -13.57. In the year 1988, what is the difference between the Electricity production(% of total) of Sub-Saharan Africa (developing only) and Electricity production(% of total) of Togo?
Your answer should be compact. -47.2. In the year 1988, what is the difference between the Electricity production(% of total) in Algeria and Electricity production(% of total) in Nicaragua?
Make the answer very short. -28.92. In the year 1988, what is the difference between the Electricity production(% of total) in Algeria and Electricity production(% of total) in Togo?
Your answer should be very brief. -62.56. In the year 1988, what is the difference between the Electricity production(% of total) of Nicaragua and Electricity production(% of total) of Togo?
Make the answer very short. -33.63. In the year 1989, what is the difference between the Electricity production(% of total) in Sub-Saharan Africa (developing only) and Electricity production(% of total) in Algeria?
Your answer should be compact. 15.25. In the year 1989, what is the difference between the Electricity production(% of total) in Sub-Saharan Africa (developing only) and Electricity production(% of total) in Nicaragua?
Offer a terse response. -17.59. In the year 1989, what is the difference between the Electricity production(% of total) of Sub-Saharan Africa (developing only) and Electricity production(% of total) of Togo?
Give a very brief answer. -57.49. In the year 1989, what is the difference between the Electricity production(% of total) in Algeria and Electricity production(% of total) in Nicaragua?
Your response must be concise. -32.84. In the year 1989, what is the difference between the Electricity production(% of total) in Algeria and Electricity production(% of total) in Togo?
Make the answer very short. -72.74. In the year 1989, what is the difference between the Electricity production(% of total) in Nicaragua and Electricity production(% of total) in Togo?
Ensure brevity in your answer.  -39.9. In the year 1990, what is the difference between the Electricity production(% of total) in Sub-Saharan Africa (developing only) and Electricity production(% of total) in Algeria?
Make the answer very short. 15.65. In the year 1990, what is the difference between the Electricity production(% of total) of Sub-Saharan Africa (developing only) and Electricity production(% of total) of Nicaragua?
Give a very brief answer. -11.17. In the year 1990, what is the difference between the Electricity production(% of total) in Sub-Saharan Africa (developing only) and Electricity production(% of total) in Togo?
Provide a short and direct response. -43.63. In the year 1990, what is the difference between the Electricity production(% of total) in Algeria and Electricity production(% of total) in Nicaragua?
Keep it short and to the point. -26.82. In the year 1990, what is the difference between the Electricity production(% of total) of Algeria and Electricity production(% of total) of Togo?
Your response must be concise. -59.29. In the year 1990, what is the difference between the Electricity production(% of total) of Nicaragua and Electricity production(% of total) of Togo?
Provide a succinct answer. -32.47. In the year 1991, what is the difference between the Electricity production(% of total) in Sub-Saharan Africa (developing only) and Electricity production(% of total) in Algeria?
Offer a very short reply. 16.28. In the year 1991, what is the difference between the Electricity production(% of total) in Sub-Saharan Africa (developing only) and Electricity production(% of total) in Nicaragua?
Your response must be concise. -4.39. In the year 1991, what is the difference between the Electricity production(% of total) in Sub-Saharan Africa (developing only) and Electricity production(% of total) in Togo?
Your response must be concise. -50.23. In the year 1991, what is the difference between the Electricity production(% of total) in Algeria and Electricity production(% of total) in Nicaragua?
Your response must be concise. -20.67. In the year 1991, what is the difference between the Electricity production(% of total) of Algeria and Electricity production(% of total) of Togo?
Make the answer very short. -66.51. In the year 1991, what is the difference between the Electricity production(% of total) of Nicaragua and Electricity production(% of total) of Togo?
Your answer should be compact. -45.84. In the year 1992, what is the difference between the Electricity production(% of total) in Sub-Saharan Africa (developing only) and Electricity production(% of total) in Algeria?
Give a very brief answer. 15.95. In the year 1992, what is the difference between the Electricity production(% of total) of Sub-Saharan Africa (developing only) and Electricity production(% of total) of Nicaragua?
Provide a succinct answer. 1.36. In the year 1992, what is the difference between the Electricity production(% of total) of Sub-Saharan Africa (developing only) and Electricity production(% of total) of Togo?
Your answer should be compact. -59.61. In the year 1992, what is the difference between the Electricity production(% of total) in Algeria and Electricity production(% of total) in Nicaragua?
Your answer should be compact. -14.59. In the year 1992, what is the difference between the Electricity production(% of total) in Algeria and Electricity production(% of total) in Togo?
Provide a short and direct response. -75.56. In the year 1992, what is the difference between the Electricity production(% of total) in Nicaragua and Electricity production(% of total) in Togo?
Give a very brief answer. -60.97. In the year 1993, what is the difference between the Electricity production(% of total) of Sub-Saharan Africa (developing only) and Electricity production(% of total) of Algeria?
Give a very brief answer. 14.32. In the year 1993, what is the difference between the Electricity production(% of total) of Sub-Saharan Africa (developing only) and Electricity production(% of total) of Nicaragua?
Keep it short and to the point. -11.7. In the year 1993, what is the difference between the Electricity production(% of total) in Sub-Saharan Africa (developing only) and Electricity production(% of total) in Togo?
Provide a succinct answer. -63.45. In the year 1993, what is the difference between the Electricity production(% of total) of Algeria and Electricity production(% of total) of Nicaragua?
Ensure brevity in your answer.  -26.02. In the year 1993, what is the difference between the Electricity production(% of total) of Algeria and Electricity production(% of total) of Togo?
Your answer should be very brief. -77.77. In the year 1993, what is the difference between the Electricity production(% of total) of Nicaragua and Electricity production(% of total) of Togo?
Give a very brief answer. -51.75. In the year 1994, what is the difference between the Electricity production(% of total) of Sub-Saharan Africa (developing only) and Electricity production(% of total) of Algeria?
Offer a terse response. 14.83. In the year 1994, what is the difference between the Electricity production(% of total) of Sub-Saharan Africa (developing only) and Electricity production(% of total) of Nicaragua?
Keep it short and to the point. -6.27. In the year 1994, what is the difference between the Electricity production(% of total) of Sub-Saharan Africa (developing only) and Electricity production(% of total) of Togo?
Your answer should be compact. -44.26. In the year 1994, what is the difference between the Electricity production(% of total) of Algeria and Electricity production(% of total) of Nicaragua?
Offer a terse response. -21.1. In the year 1994, what is the difference between the Electricity production(% of total) of Algeria and Electricity production(% of total) of Togo?
Ensure brevity in your answer.  -59.08. In the year 1994, what is the difference between the Electricity production(% of total) in Nicaragua and Electricity production(% of total) in Togo?
Your response must be concise. -37.98. What is the ratio of the Electricity production(% of total) of Sub-Saharan Africa (developing only) in 1987 to that in 1988?
Ensure brevity in your answer.  0.91. What is the ratio of the Electricity production(% of total) of Algeria in 1987 to that in 1988?
Provide a succinct answer. 2.99. What is the ratio of the Electricity production(% of total) in Nicaragua in 1987 to that in 1988?
Make the answer very short. 1.04. What is the ratio of the Electricity production(% of total) of Togo in 1987 to that in 1988?
Provide a succinct answer. 1.07. What is the ratio of the Electricity production(% of total) of Sub-Saharan Africa (developing only) in 1987 to that in 1989?
Make the answer very short. 0.91. What is the ratio of the Electricity production(% of total) of Algeria in 1987 to that in 1989?
Your answer should be compact. 2.66. What is the ratio of the Electricity production(% of total) of Nicaragua in 1987 to that in 1989?
Your response must be concise. 0.91. What is the ratio of the Electricity production(% of total) of Togo in 1987 to that in 1989?
Your answer should be very brief. 0.92. What is the ratio of the Electricity production(% of total) in Sub-Saharan Africa (developing only) in 1987 to that in 1990?
Your answer should be very brief. 0.92. What is the ratio of the Electricity production(% of total) in Algeria in 1987 to that in 1990?
Make the answer very short. 4.68. What is the ratio of the Electricity production(% of total) of Nicaragua in 1987 to that in 1990?
Your answer should be very brief. 1.13. What is the ratio of the Electricity production(% of total) in Togo in 1987 to that in 1990?
Keep it short and to the point. 1.14. What is the ratio of the Electricity production(% of total) of Sub-Saharan Africa (developing only) in 1987 to that in 1991?
Provide a short and direct response. 0.84. What is the ratio of the Electricity production(% of total) in Algeria in 1987 to that in 1991?
Give a very brief answer. 2.32. What is the ratio of the Electricity production(% of total) in Nicaragua in 1987 to that in 1991?
Your answer should be compact. 1.4. What is the ratio of the Electricity production(% of total) in Sub-Saharan Africa (developing only) in 1987 to that in 1992?
Keep it short and to the point. 0.89. What is the ratio of the Electricity production(% of total) of Algeria in 1987 to that in 1992?
Your response must be concise. 3.6. What is the ratio of the Electricity production(% of total) in Nicaragua in 1987 to that in 1992?
Ensure brevity in your answer.  2. What is the ratio of the Electricity production(% of total) in Togo in 1987 to that in 1992?
Your answer should be very brief. 0.89. What is the ratio of the Electricity production(% of total) in Sub-Saharan Africa (developing only) in 1987 to that in 1993?
Your response must be concise. 0.94. What is the ratio of the Electricity production(% of total) of Algeria in 1987 to that in 1993?
Keep it short and to the point. 2.16. What is the ratio of the Electricity production(% of total) of Nicaragua in 1987 to that in 1993?
Provide a succinct answer. 1.13. What is the ratio of the Electricity production(% of total) of Togo in 1987 to that in 1993?
Provide a succinct answer. 0.86. What is the ratio of the Electricity production(% of total) of Sub-Saharan Africa (developing only) in 1987 to that in 1994?
Offer a terse response. 0.97. What is the ratio of the Electricity production(% of total) of Algeria in 1987 to that in 1994?
Offer a very short reply. 4.7. What is the ratio of the Electricity production(% of total) of Nicaragua in 1987 to that in 1994?
Offer a terse response. 1.43. What is the ratio of the Electricity production(% of total) of Togo in 1987 to that in 1994?
Offer a very short reply. 1.14. What is the ratio of the Electricity production(% of total) of Sub-Saharan Africa (developing only) in 1988 to that in 1989?
Your answer should be very brief. 1. What is the ratio of the Electricity production(% of total) in Algeria in 1988 to that in 1989?
Give a very brief answer. 0.89. What is the ratio of the Electricity production(% of total) of Nicaragua in 1988 to that in 1989?
Offer a terse response. 0.88. What is the ratio of the Electricity production(% of total) in Togo in 1988 to that in 1989?
Provide a short and direct response. 0.86. What is the ratio of the Electricity production(% of total) in Sub-Saharan Africa (developing only) in 1988 to that in 1990?
Your response must be concise. 1.01. What is the ratio of the Electricity production(% of total) in Algeria in 1988 to that in 1990?
Your response must be concise. 1.56. What is the ratio of the Electricity production(% of total) of Nicaragua in 1988 to that in 1990?
Provide a succinct answer. 1.09. What is the ratio of the Electricity production(% of total) of Togo in 1988 to that in 1990?
Provide a succinct answer. 1.06. What is the ratio of the Electricity production(% of total) of Sub-Saharan Africa (developing only) in 1988 to that in 1991?
Keep it short and to the point. 0.93. What is the ratio of the Electricity production(% of total) in Algeria in 1988 to that in 1991?
Offer a terse response. 0.78. What is the ratio of the Electricity production(% of total) in Nicaragua in 1988 to that in 1991?
Offer a very short reply. 1.35. What is the ratio of the Electricity production(% of total) of Togo in 1988 to that in 1991?
Your answer should be compact. 0.94. What is the ratio of the Electricity production(% of total) of Sub-Saharan Africa (developing only) in 1988 to that in 1992?
Offer a terse response. 0.98. What is the ratio of the Electricity production(% of total) in Algeria in 1988 to that in 1992?
Ensure brevity in your answer.  1.2. What is the ratio of the Electricity production(% of total) in Nicaragua in 1988 to that in 1992?
Offer a very short reply. 1.93. What is the ratio of the Electricity production(% of total) in Togo in 1988 to that in 1992?
Offer a terse response. 0.83. What is the ratio of the Electricity production(% of total) in Sub-Saharan Africa (developing only) in 1988 to that in 1993?
Keep it short and to the point. 1.03. What is the ratio of the Electricity production(% of total) in Algeria in 1988 to that in 1993?
Your answer should be very brief. 0.72. What is the ratio of the Electricity production(% of total) of Nicaragua in 1988 to that in 1993?
Provide a short and direct response. 1.09. What is the ratio of the Electricity production(% of total) in Togo in 1988 to that in 1993?
Offer a very short reply. 0.8. What is the ratio of the Electricity production(% of total) in Sub-Saharan Africa (developing only) in 1988 to that in 1994?
Offer a very short reply. 1.06. What is the ratio of the Electricity production(% of total) in Algeria in 1988 to that in 1994?
Offer a terse response. 1.57. What is the ratio of the Electricity production(% of total) of Nicaragua in 1988 to that in 1994?
Keep it short and to the point. 1.38. What is the ratio of the Electricity production(% of total) in Togo in 1988 to that in 1994?
Your answer should be compact. 1.07. What is the ratio of the Electricity production(% of total) in Sub-Saharan Africa (developing only) in 1989 to that in 1990?
Offer a terse response. 1.01. What is the ratio of the Electricity production(% of total) of Algeria in 1989 to that in 1990?
Give a very brief answer. 1.76. What is the ratio of the Electricity production(% of total) in Nicaragua in 1989 to that in 1990?
Your response must be concise. 1.24. What is the ratio of the Electricity production(% of total) of Togo in 1989 to that in 1990?
Provide a short and direct response. 1.23. What is the ratio of the Electricity production(% of total) of Sub-Saharan Africa (developing only) in 1989 to that in 1991?
Keep it short and to the point. 0.93. What is the ratio of the Electricity production(% of total) in Algeria in 1989 to that in 1991?
Your answer should be very brief. 0.87. What is the ratio of the Electricity production(% of total) in Nicaragua in 1989 to that in 1991?
Offer a terse response. 1.53. What is the ratio of the Electricity production(% of total) in Togo in 1989 to that in 1991?
Keep it short and to the point. 1.09. What is the ratio of the Electricity production(% of total) of Sub-Saharan Africa (developing only) in 1989 to that in 1992?
Ensure brevity in your answer.  0.98. What is the ratio of the Electricity production(% of total) of Algeria in 1989 to that in 1992?
Offer a terse response. 1.36. What is the ratio of the Electricity production(% of total) of Nicaragua in 1989 to that in 1992?
Your answer should be compact. 2.19. What is the ratio of the Electricity production(% of total) in Togo in 1989 to that in 1992?
Keep it short and to the point. 0.97. What is the ratio of the Electricity production(% of total) of Sub-Saharan Africa (developing only) in 1989 to that in 1993?
Your answer should be very brief. 1.04. What is the ratio of the Electricity production(% of total) of Algeria in 1989 to that in 1993?
Ensure brevity in your answer.  0.81. What is the ratio of the Electricity production(% of total) of Nicaragua in 1989 to that in 1993?
Ensure brevity in your answer.  1.23. What is the ratio of the Electricity production(% of total) of Togo in 1989 to that in 1993?
Offer a terse response. 0.93. What is the ratio of the Electricity production(% of total) in Sub-Saharan Africa (developing only) in 1989 to that in 1994?
Your response must be concise. 1.07. What is the ratio of the Electricity production(% of total) in Algeria in 1989 to that in 1994?
Provide a short and direct response. 1.77. What is the ratio of the Electricity production(% of total) in Nicaragua in 1989 to that in 1994?
Your response must be concise. 1.56. What is the ratio of the Electricity production(% of total) of Togo in 1989 to that in 1994?
Provide a succinct answer. 1.24. What is the ratio of the Electricity production(% of total) of Sub-Saharan Africa (developing only) in 1990 to that in 1991?
Your answer should be compact. 0.92. What is the ratio of the Electricity production(% of total) in Algeria in 1990 to that in 1991?
Your answer should be compact. 0.5. What is the ratio of the Electricity production(% of total) in Nicaragua in 1990 to that in 1991?
Offer a terse response. 1.24. What is the ratio of the Electricity production(% of total) of Togo in 1990 to that in 1991?
Keep it short and to the point. 0.88. What is the ratio of the Electricity production(% of total) of Sub-Saharan Africa (developing only) in 1990 to that in 1992?
Provide a short and direct response. 0.97. What is the ratio of the Electricity production(% of total) in Algeria in 1990 to that in 1992?
Your response must be concise. 0.77. What is the ratio of the Electricity production(% of total) in Nicaragua in 1990 to that in 1992?
Offer a terse response. 1.76. What is the ratio of the Electricity production(% of total) of Togo in 1990 to that in 1992?
Offer a terse response. 0.78. What is the ratio of the Electricity production(% of total) in Sub-Saharan Africa (developing only) in 1990 to that in 1993?
Offer a terse response. 1.02. What is the ratio of the Electricity production(% of total) in Algeria in 1990 to that in 1993?
Offer a very short reply. 0.46. What is the ratio of the Electricity production(% of total) in Togo in 1990 to that in 1993?
Your response must be concise. 0.76. What is the ratio of the Electricity production(% of total) of Sub-Saharan Africa (developing only) in 1990 to that in 1994?
Offer a very short reply. 1.05. What is the ratio of the Electricity production(% of total) in Algeria in 1990 to that in 1994?
Your answer should be very brief. 1. What is the ratio of the Electricity production(% of total) of Nicaragua in 1990 to that in 1994?
Your response must be concise. 1.26. What is the ratio of the Electricity production(% of total) of Sub-Saharan Africa (developing only) in 1991 to that in 1992?
Ensure brevity in your answer.  1.05. What is the ratio of the Electricity production(% of total) in Algeria in 1991 to that in 1992?
Offer a terse response. 1.55. What is the ratio of the Electricity production(% of total) of Nicaragua in 1991 to that in 1992?
Your answer should be very brief. 1.43. What is the ratio of the Electricity production(% of total) of Togo in 1991 to that in 1992?
Your response must be concise. 0.89. What is the ratio of the Electricity production(% of total) of Sub-Saharan Africa (developing only) in 1991 to that in 1993?
Provide a short and direct response. 1.11. What is the ratio of the Electricity production(% of total) in Algeria in 1991 to that in 1993?
Offer a terse response. 0.93. What is the ratio of the Electricity production(% of total) in Nicaragua in 1991 to that in 1993?
Make the answer very short. 0.8. What is the ratio of the Electricity production(% of total) of Togo in 1991 to that in 1993?
Offer a terse response. 0.86. What is the ratio of the Electricity production(% of total) in Sub-Saharan Africa (developing only) in 1991 to that in 1994?
Ensure brevity in your answer.  1.15. What is the ratio of the Electricity production(% of total) in Algeria in 1991 to that in 1994?
Offer a terse response. 2.02. What is the ratio of the Electricity production(% of total) in Nicaragua in 1991 to that in 1994?
Give a very brief answer. 1.02. What is the ratio of the Electricity production(% of total) in Togo in 1991 to that in 1994?
Offer a terse response. 1.14. What is the ratio of the Electricity production(% of total) of Sub-Saharan Africa (developing only) in 1992 to that in 1993?
Offer a very short reply. 1.06. What is the ratio of the Electricity production(% of total) of Algeria in 1992 to that in 1993?
Keep it short and to the point. 0.6. What is the ratio of the Electricity production(% of total) in Nicaragua in 1992 to that in 1993?
Provide a short and direct response. 0.56. What is the ratio of the Electricity production(% of total) in Togo in 1992 to that in 1993?
Provide a succinct answer. 0.96. What is the ratio of the Electricity production(% of total) in Sub-Saharan Africa (developing only) in 1992 to that in 1994?
Provide a succinct answer. 1.09. What is the ratio of the Electricity production(% of total) in Algeria in 1992 to that in 1994?
Ensure brevity in your answer.  1.3. What is the ratio of the Electricity production(% of total) in Nicaragua in 1992 to that in 1994?
Your answer should be very brief. 0.71. What is the ratio of the Electricity production(% of total) in Togo in 1992 to that in 1994?
Give a very brief answer. 1.28. What is the ratio of the Electricity production(% of total) in Sub-Saharan Africa (developing only) in 1993 to that in 1994?
Keep it short and to the point. 1.03. What is the ratio of the Electricity production(% of total) of Algeria in 1993 to that in 1994?
Your response must be concise. 2.18. What is the ratio of the Electricity production(% of total) in Nicaragua in 1993 to that in 1994?
Your response must be concise. 1.27. What is the ratio of the Electricity production(% of total) of Togo in 1993 to that in 1994?
Ensure brevity in your answer.  1.33. What is the difference between the highest and the second highest Electricity production(% of total) in Sub-Saharan Africa (developing only)?
Your answer should be very brief. 0.93. What is the difference between the highest and the second highest Electricity production(% of total) in Algeria?
Offer a very short reply. 2.1. What is the difference between the highest and the second highest Electricity production(% of total) in Nicaragua?
Provide a succinct answer. 2.94. What is the difference between the highest and the second highest Electricity production(% of total) in Togo?
Offer a very short reply. 2.94. What is the difference between the highest and the lowest Electricity production(% of total) in Sub-Saharan Africa (developing only)?
Your answer should be compact. 2.8. What is the difference between the highest and the lowest Electricity production(% of total) in Algeria?
Your response must be concise. 3.09. What is the difference between the highest and the lowest Electricity production(% of total) of Nicaragua?
Your answer should be very brief. 18.64. What is the difference between the highest and the lowest Electricity production(% of total) of Togo?
Offer a terse response. 19.67. 